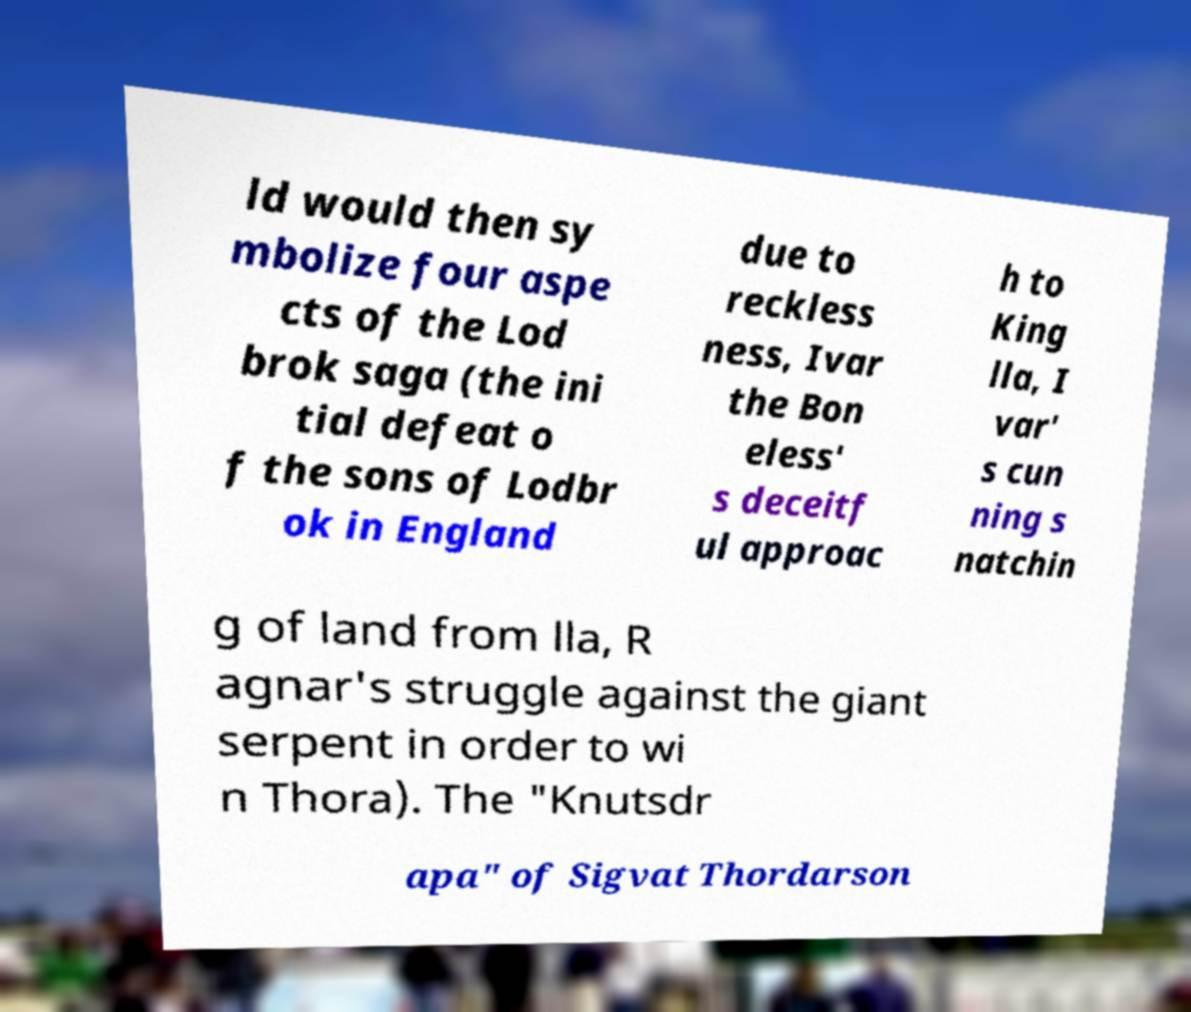For documentation purposes, I need the text within this image transcribed. Could you provide that? ld would then sy mbolize four aspe cts of the Lod brok saga (the ini tial defeat o f the sons of Lodbr ok in England due to reckless ness, Ivar the Bon eless' s deceitf ul approac h to King lla, I var' s cun ning s natchin g of land from lla, R agnar's struggle against the giant serpent in order to wi n Thora). The "Knutsdr apa" of Sigvat Thordarson 